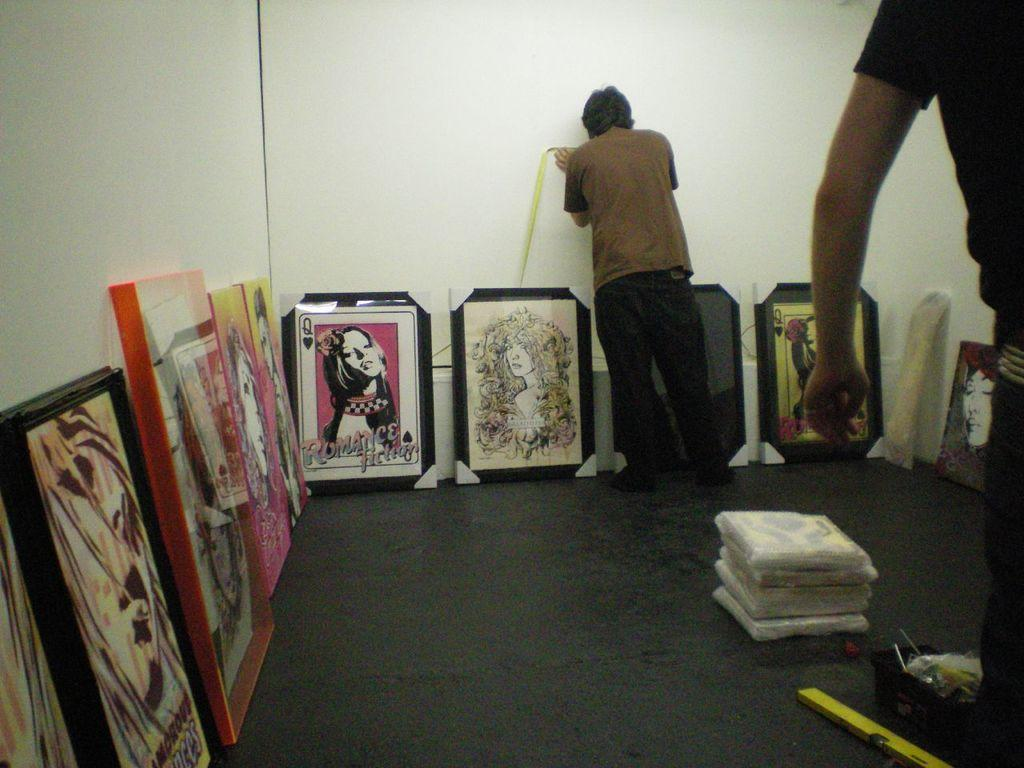Provide a one-sentence caption for the provided image. Two men are working around paintings on the floor one of which says "romance" on the bottom in pink letters. 